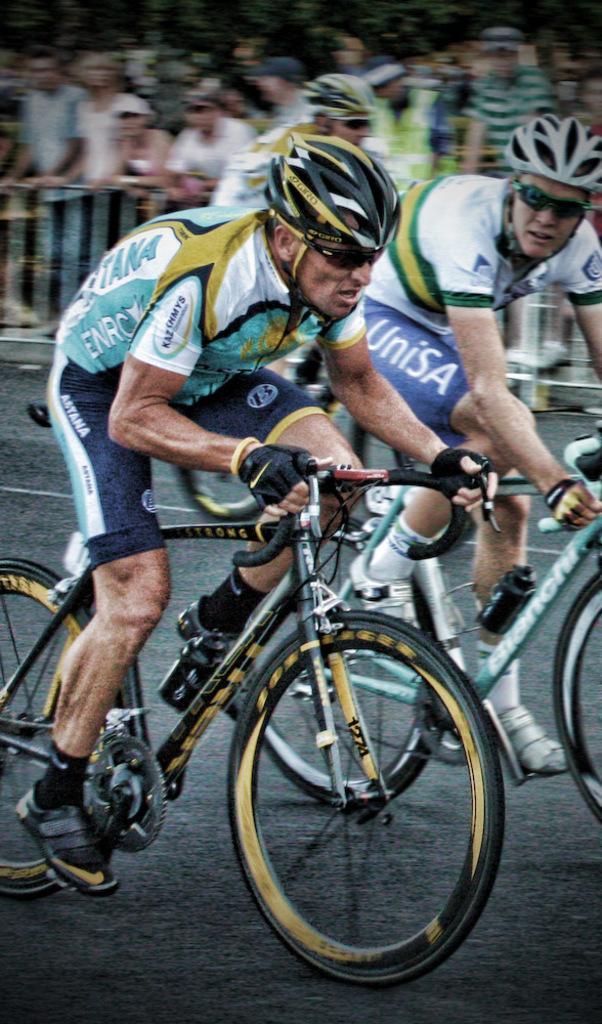Describe this image in one or two sentences. As we can see in the image in the front there are two people wearing helmets and riding bicycles. In the background there are group of people watching them. 